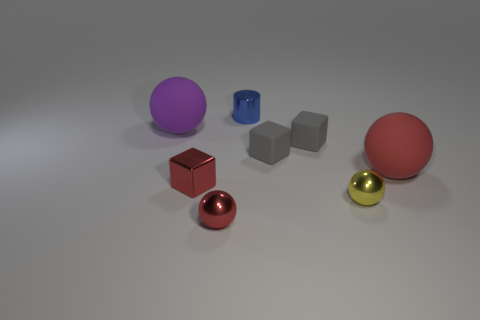Is there any other thing that is the same color as the tiny metallic cube?
Offer a terse response. Yes. Does the big thing right of the small blue thing have the same color as the shiny block?
Provide a succinct answer. Yes. Is the tiny cylinder made of the same material as the big purple thing?
Offer a very short reply. No. What number of tiny shiny things are in front of the tiny red object that is behind the tiny sphere to the left of the small yellow metallic sphere?
Offer a very short reply. 2. What color is the small ball that is right of the tiny blue cylinder?
Keep it short and to the point. Yellow. What shape is the tiny thing that is behind the big rubber sphere to the left of the large red matte thing?
Give a very brief answer. Cylinder. What number of balls are either gray rubber things or big red rubber objects?
Your answer should be compact. 1. There is a red thing that is both behind the small yellow metallic object and on the left side of the red matte object; what is its material?
Offer a terse response. Metal. How many big purple matte objects are to the left of the large red matte sphere?
Your response must be concise. 1. Are the tiny thing that is behind the purple rubber sphere and the large ball right of the cylinder made of the same material?
Your response must be concise. No. 